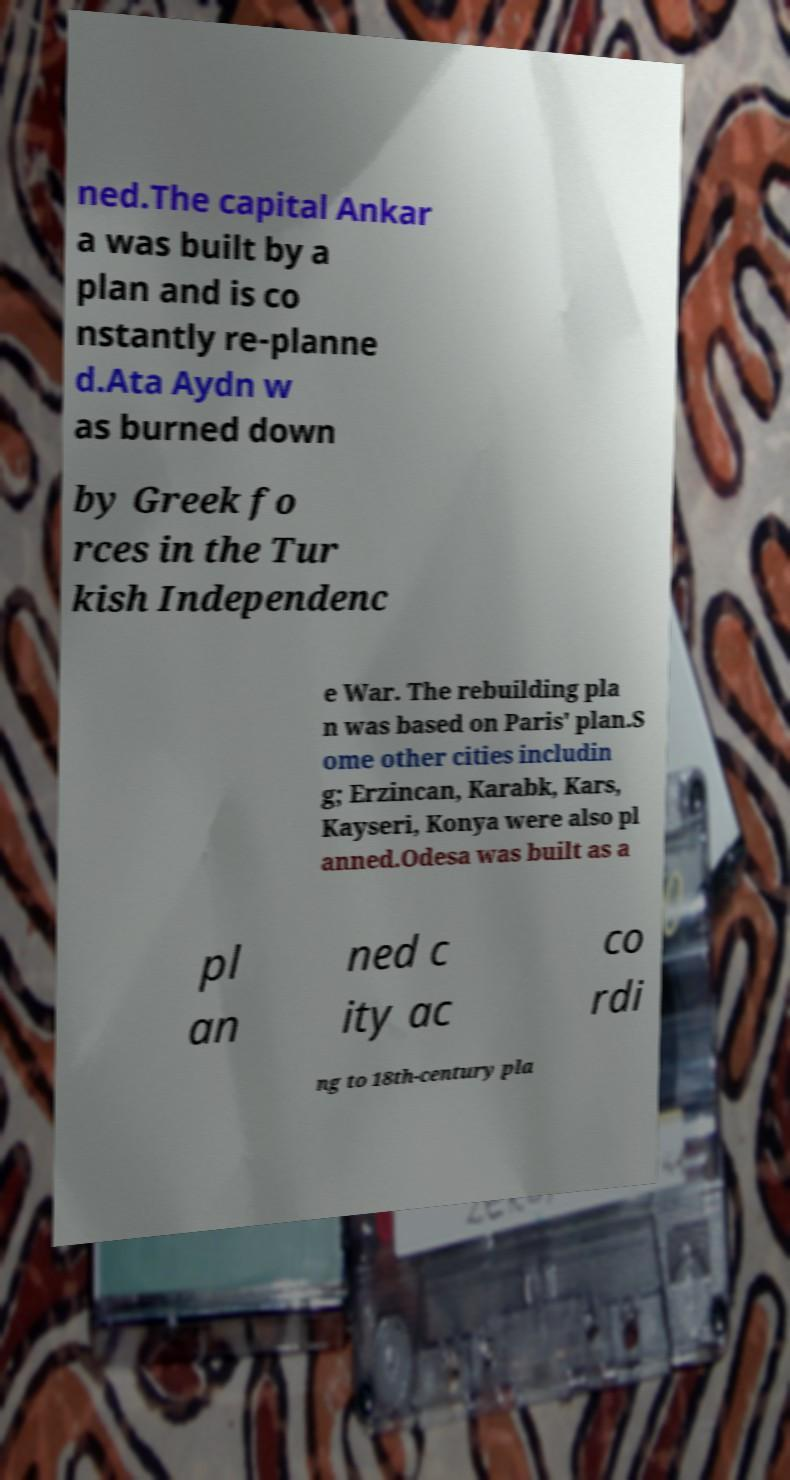What messages or text are displayed in this image? I need them in a readable, typed format. ned.The capital Ankar a was built by a plan and is co nstantly re-planne d.Ata Aydn w as burned down by Greek fo rces in the Tur kish Independenc e War. The rebuilding pla n was based on Paris' plan.S ome other cities includin g; Erzincan, Karabk, Kars, Kayseri, Konya were also pl anned.Odesa was built as a pl an ned c ity ac co rdi ng to 18th-century pla 